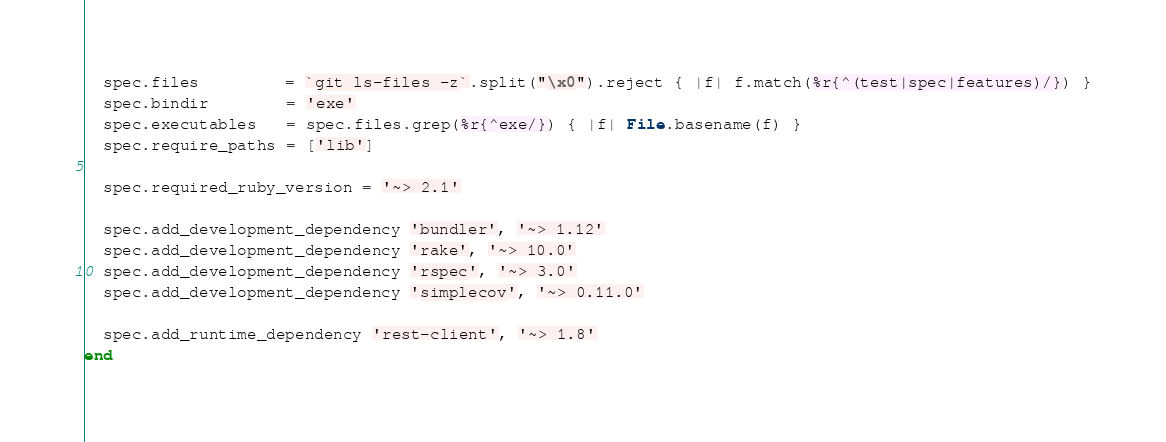<code> <loc_0><loc_0><loc_500><loc_500><_Ruby_>  spec.files         = `git ls-files -z`.split("\x0").reject { |f| f.match(%r{^(test|spec|features)/}) }
  spec.bindir        = 'exe'
  spec.executables   = spec.files.grep(%r{^exe/}) { |f| File.basename(f) }
  spec.require_paths = ['lib']

  spec.required_ruby_version = '~> 2.1'

  spec.add_development_dependency 'bundler', '~> 1.12'
  spec.add_development_dependency 'rake', '~> 10.0'
  spec.add_development_dependency 'rspec', '~> 3.0'
  spec.add_development_dependency 'simplecov', '~> 0.11.0'

  spec.add_runtime_dependency 'rest-client', '~> 1.8'
end
</code> 